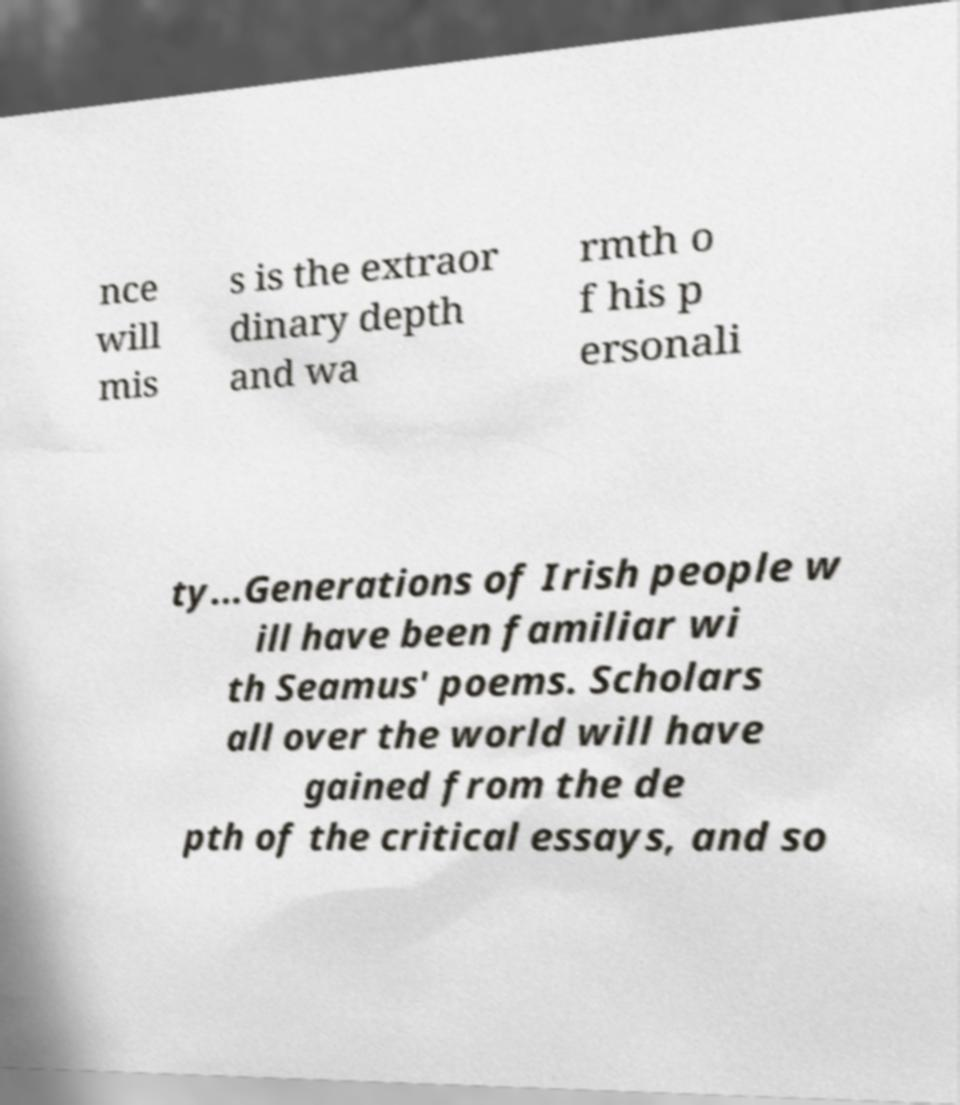Can you accurately transcribe the text from the provided image for me? nce will mis s is the extraor dinary depth and wa rmth o f his p ersonali ty...Generations of Irish people w ill have been familiar wi th Seamus' poems. Scholars all over the world will have gained from the de pth of the critical essays, and so 